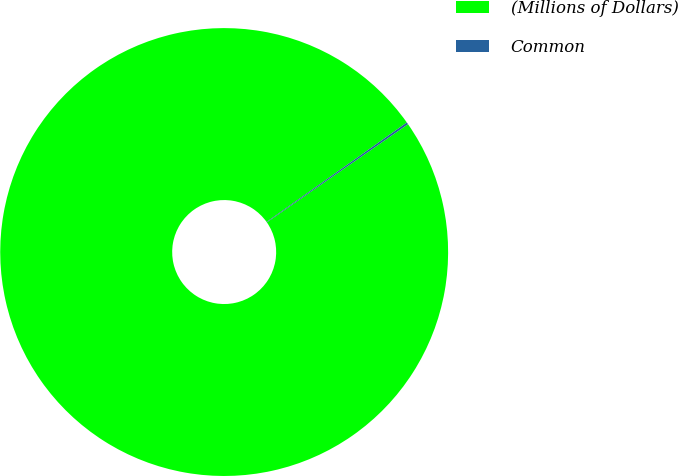Convert chart to OTSL. <chart><loc_0><loc_0><loc_500><loc_500><pie_chart><fcel>(Millions of Dollars)<fcel>Common<nl><fcel>99.85%<fcel>0.15%<nl></chart> 